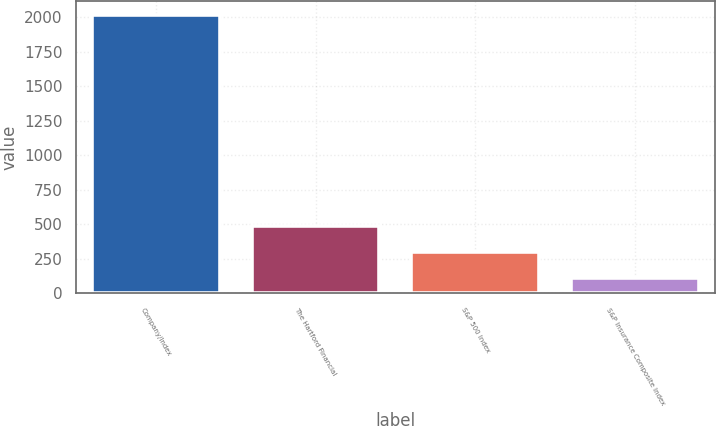<chart> <loc_0><loc_0><loc_500><loc_500><bar_chart><fcel>Company/Index<fcel>The Hartford Financial<fcel>S&P 500 Index<fcel>S&P Insurance Composite Index<nl><fcel>2015<fcel>491.65<fcel>301.23<fcel>110.81<nl></chart> 